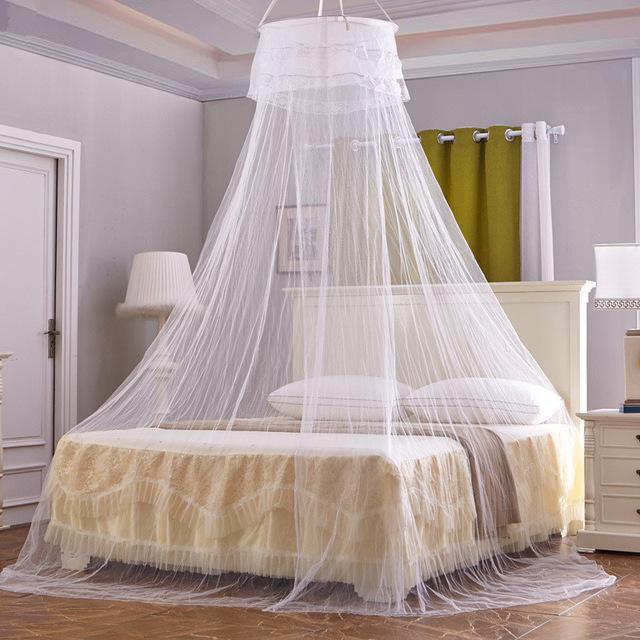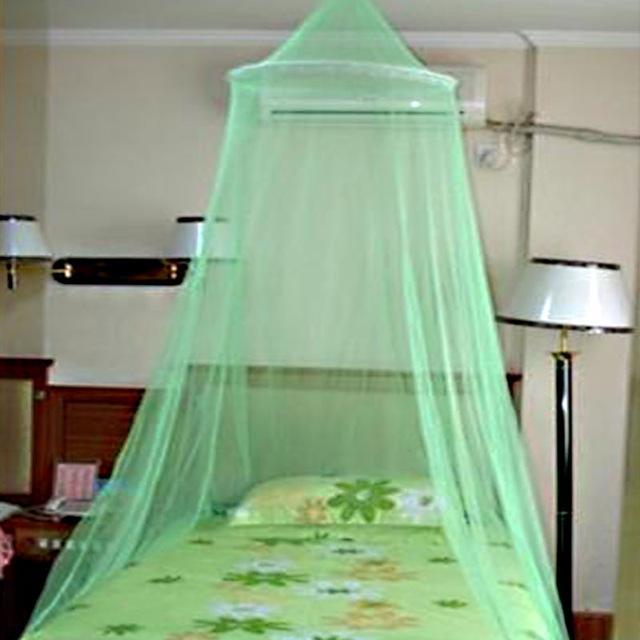The first image is the image on the left, the second image is the image on the right. Analyze the images presented: Is the assertion "Each image shows a gauzy canopy that drapes from a round shape suspended from the ceiling, and the right image features an aqua canopy with a ruffle around the top." valid? Answer yes or no. No. The first image is the image on the left, the second image is the image on the right. Evaluate the accuracy of this statement regarding the images: "The left and right image contains the same number of canopies with at least one green one.". Is it true? Answer yes or no. Yes. 